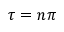<formula> <loc_0><loc_0><loc_500><loc_500>\tau = n \pi</formula> 